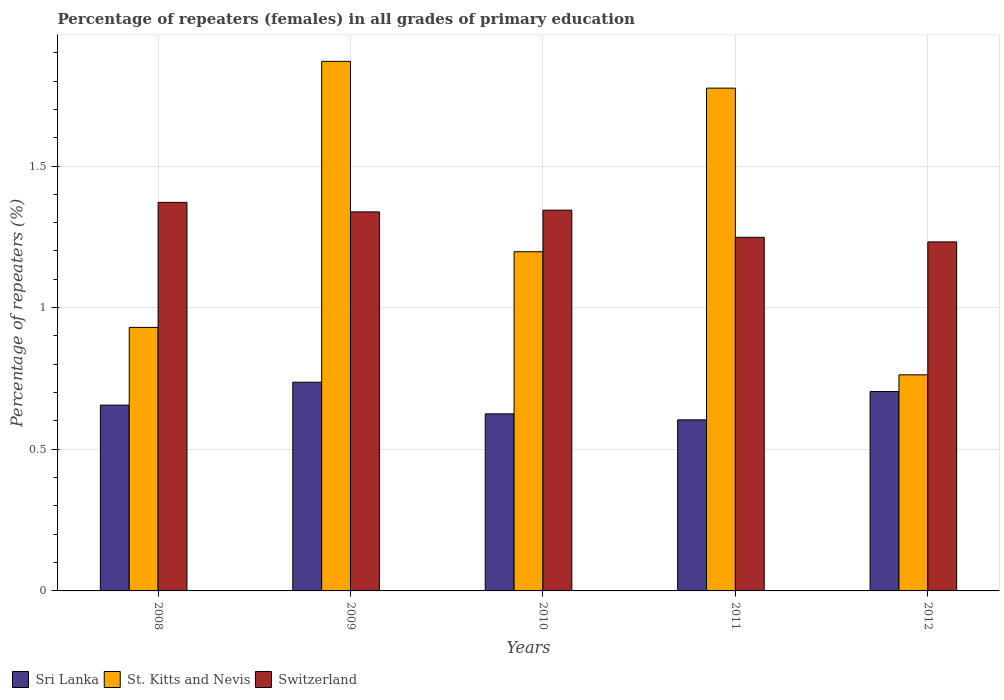How many groups of bars are there?
Your answer should be compact. 5. Are the number of bars per tick equal to the number of legend labels?
Your answer should be compact. Yes. How many bars are there on the 4th tick from the left?
Provide a short and direct response. 3. How many bars are there on the 2nd tick from the right?
Your response must be concise. 3. In how many cases, is the number of bars for a given year not equal to the number of legend labels?
Your response must be concise. 0. What is the percentage of repeaters (females) in St. Kitts and Nevis in 2011?
Provide a succinct answer. 1.77. Across all years, what is the maximum percentage of repeaters (females) in Switzerland?
Provide a short and direct response. 1.37. Across all years, what is the minimum percentage of repeaters (females) in St. Kitts and Nevis?
Provide a short and direct response. 0.76. In which year was the percentage of repeaters (females) in Sri Lanka maximum?
Your answer should be very brief. 2009. In which year was the percentage of repeaters (females) in St. Kitts and Nevis minimum?
Offer a very short reply. 2012. What is the total percentage of repeaters (females) in Switzerland in the graph?
Offer a very short reply. 6.53. What is the difference between the percentage of repeaters (females) in Switzerland in 2011 and that in 2012?
Your answer should be compact. 0.02. What is the difference between the percentage of repeaters (females) in St. Kitts and Nevis in 2009 and the percentage of repeaters (females) in Switzerland in 2012?
Offer a very short reply. 0.64. What is the average percentage of repeaters (females) in Sri Lanka per year?
Keep it short and to the point. 0.67. In the year 2009, what is the difference between the percentage of repeaters (females) in St. Kitts and Nevis and percentage of repeaters (females) in Switzerland?
Offer a very short reply. 0.53. In how many years, is the percentage of repeaters (females) in Switzerland greater than 1.2 %?
Offer a terse response. 5. What is the ratio of the percentage of repeaters (females) in Sri Lanka in 2010 to that in 2011?
Your answer should be very brief. 1.04. Is the difference between the percentage of repeaters (females) in St. Kitts and Nevis in 2009 and 2010 greater than the difference between the percentage of repeaters (females) in Switzerland in 2009 and 2010?
Make the answer very short. Yes. What is the difference between the highest and the second highest percentage of repeaters (females) in Sri Lanka?
Give a very brief answer. 0.03. What is the difference between the highest and the lowest percentage of repeaters (females) in Sri Lanka?
Your answer should be compact. 0.13. What does the 2nd bar from the left in 2010 represents?
Keep it short and to the point. St. Kitts and Nevis. What does the 3rd bar from the right in 2009 represents?
Your answer should be very brief. Sri Lanka. Is it the case that in every year, the sum of the percentage of repeaters (females) in St. Kitts and Nevis and percentage of repeaters (females) in Sri Lanka is greater than the percentage of repeaters (females) in Switzerland?
Keep it short and to the point. Yes. How many bars are there?
Make the answer very short. 15. What is the difference between two consecutive major ticks on the Y-axis?
Your answer should be compact. 0.5. Does the graph contain grids?
Your answer should be very brief. Yes. Where does the legend appear in the graph?
Your answer should be compact. Bottom left. How many legend labels are there?
Your response must be concise. 3. How are the legend labels stacked?
Your answer should be compact. Horizontal. What is the title of the graph?
Your answer should be compact. Percentage of repeaters (females) in all grades of primary education. Does "Papua New Guinea" appear as one of the legend labels in the graph?
Your response must be concise. No. What is the label or title of the Y-axis?
Provide a short and direct response. Percentage of repeaters (%). What is the Percentage of repeaters (%) of Sri Lanka in 2008?
Ensure brevity in your answer.  0.66. What is the Percentage of repeaters (%) in St. Kitts and Nevis in 2008?
Offer a terse response. 0.93. What is the Percentage of repeaters (%) in Switzerland in 2008?
Make the answer very short. 1.37. What is the Percentage of repeaters (%) in Sri Lanka in 2009?
Give a very brief answer. 0.74. What is the Percentage of repeaters (%) of St. Kitts and Nevis in 2009?
Make the answer very short. 1.87. What is the Percentage of repeaters (%) in Switzerland in 2009?
Give a very brief answer. 1.34. What is the Percentage of repeaters (%) in Sri Lanka in 2010?
Give a very brief answer. 0.63. What is the Percentage of repeaters (%) of St. Kitts and Nevis in 2010?
Provide a succinct answer. 1.2. What is the Percentage of repeaters (%) in Switzerland in 2010?
Your answer should be very brief. 1.34. What is the Percentage of repeaters (%) in Sri Lanka in 2011?
Keep it short and to the point. 0.6. What is the Percentage of repeaters (%) of St. Kitts and Nevis in 2011?
Provide a succinct answer. 1.77. What is the Percentage of repeaters (%) in Switzerland in 2011?
Provide a succinct answer. 1.25. What is the Percentage of repeaters (%) of Sri Lanka in 2012?
Give a very brief answer. 0.7. What is the Percentage of repeaters (%) of St. Kitts and Nevis in 2012?
Provide a succinct answer. 0.76. What is the Percentage of repeaters (%) of Switzerland in 2012?
Provide a succinct answer. 1.23. Across all years, what is the maximum Percentage of repeaters (%) in Sri Lanka?
Provide a succinct answer. 0.74. Across all years, what is the maximum Percentage of repeaters (%) of St. Kitts and Nevis?
Make the answer very short. 1.87. Across all years, what is the maximum Percentage of repeaters (%) in Switzerland?
Your response must be concise. 1.37. Across all years, what is the minimum Percentage of repeaters (%) in Sri Lanka?
Your answer should be compact. 0.6. Across all years, what is the minimum Percentage of repeaters (%) of St. Kitts and Nevis?
Provide a short and direct response. 0.76. Across all years, what is the minimum Percentage of repeaters (%) of Switzerland?
Provide a succinct answer. 1.23. What is the total Percentage of repeaters (%) of Sri Lanka in the graph?
Provide a short and direct response. 3.33. What is the total Percentage of repeaters (%) of St. Kitts and Nevis in the graph?
Offer a terse response. 6.53. What is the total Percentage of repeaters (%) in Switzerland in the graph?
Your response must be concise. 6.53. What is the difference between the Percentage of repeaters (%) in Sri Lanka in 2008 and that in 2009?
Your answer should be very brief. -0.08. What is the difference between the Percentage of repeaters (%) in St. Kitts and Nevis in 2008 and that in 2009?
Offer a terse response. -0.94. What is the difference between the Percentage of repeaters (%) in Switzerland in 2008 and that in 2009?
Your response must be concise. 0.03. What is the difference between the Percentage of repeaters (%) of Sri Lanka in 2008 and that in 2010?
Your answer should be compact. 0.03. What is the difference between the Percentage of repeaters (%) of St. Kitts and Nevis in 2008 and that in 2010?
Provide a succinct answer. -0.27. What is the difference between the Percentage of repeaters (%) of Switzerland in 2008 and that in 2010?
Make the answer very short. 0.03. What is the difference between the Percentage of repeaters (%) of Sri Lanka in 2008 and that in 2011?
Your answer should be compact. 0.05. What is the difference between the Percentage of repeaters (%) of St. Kitts and Nevis in 2008 and that in 2011?
Your answer should be compact. -0.84. What is the difference between the Percentage of repeaters (%) of Switzerland in 2008 and that in 2011?
Provide a succinct answer. 0.12. What is the difference between the Percentage of repeaters (%) of Sri Lanka in 2008 and that in 2012?
Give a very brief answer. -0.05. What is the difference between the Percentage of repeaters (%) of St. Kitts and Nevis in 2008 and that in 2012?
Your answer should be compact. 0.17. What is the difference between the Percentage of repeaters (%) of Switzerland in 2008 and that in 2012?
Your answer should be compact. 0.14. What is the difference between the Percentage of repeaters (%) in Sri Lanka in 2009 and that in 2010?
Ensure brevity in your answer.  0.11. What is the difference between the Percentage of repeaters (%) in St. Kitts and Nevis in 2009 and that in 2010?
Make the answer very short. 0.67. What is the difference between the Percentage of repeaters (%) of Switzerland in 2009 and that in 2010?
Your answer should be very brief. -0.01. What is the difference between the Percentage of repeaters (%) in Sri Lanka in 2009 and that in 2011?
Provide a succinct answer. 0.13. What is the difference between the Percentage of repeaters (%) of St. Kitts and Nevis in 2009 and that in 2011?
Your answer should be compact. 0.09. What is the difference between the Percentage of repeaters (%) in Switzerland in 2009 and that in 2011?
Offer a very short reply. 0.09. What is the difference between the Percentage of repeaters (%) in Sri Lanka in 2009 and that in 2012?
Your response must be concise. 0.03. What is the difference between the Percentage of repeaters (%) in St. Kitts and Nevis in 2009 and that in 2012?
Your answer should be compact. 1.11. What is the difference between the Percentage of repeaters (%) in Switzerland in 2009 and that in 2012?
Keep it short and to the point. 0.11. What is the difference between the Percentage of repeaters (%) in Sri Lanka in 2010 and that in 2011?
Your response must be concise. 0.02. What is the difference between the Percentage of repeaters (%) of St. Kitts and Nevis in 2010 and that in 2011?
Provide a succinct answer. -0.58. What is the difference between the Percentage of repeaters (%) in Switzerland in 2010 and that in 2011?
Offer a terse response. 0.1. What is the difference between the Percentage of repeaters (%) of Sri Lanka in 2010 and that in 2012?
Give a very brief answer. -0.08. What is the difference between the Percentage of repeaters (%) of St. Kitts and Nevis in 2010 and that in 2012?
Offer a terse response. 0.43. What is the difference between the Percentage of repeaters (%) in Switzerland in 2010 and that in 2012?
Provide a short and direct response. 0.11. What is the difference between the Percentage of repeaters (%) in Sri Lanka in 2011 and that in 2012?
Your response must be concise. -0.1. What is the difference between the Percentage of repeaters (%) in St. Kitts and Nevis in 2011 and that in 2012?
Your answer should be very brief. 1.01. What is the difference between the Percentage of repeaters (%) in Switzerland in 2011 and that in 2012?
Your answer should be compact. 0.02. What is the difference between the Percentage of repeaters (%) in Sri Lanka in 2008 and the Percentage of repeaters (%) in St. Kitts and Nevis in 2009?
Your response must be concise. -1.21. What is the difference between the Percentage of repeaters (%) of Sri Lanka in 2008 and the Percentage of repeaters (%) of Switzerland in 2009?
Make the answer very short. -0.68. What is the difference between the Percentage of repeaters (%) in St. Kitts and Nevis in 2008 and the Percentage of repeaters (%) in Switzerland in 2009?
Your answer should be very brief. -0.41. What is the difference between the Percentage of repeaters (%) in Sri Lanka in 2008 and the Percentage of repeaters (%) in St. Kitts and Nevis in 2010?
Offer a very short reply. -0.54. What is the difference between the Percentage of repeaters (%) in Sri Lanka in 2008 and the Percentage of repeaters (%) in Switzerland in 2010?
Keep it short and to the point. -0.69. What is the difference between the Percentage of repeaters (%) of St. Kitts and Nevis in 2008 and the Percentage of repeaters (%) of Switzerland in 2010?
Keep it short and to the point. -0.41. What is the difference between the Percentage of repeaters (%) of Sri Lanka in 2008 and the Percentage of repeaters (%) of St. Kitts and Nevis in 2011?
Keep it short and to the point. -1.12. What is the difference between the Percentage of repeaters (%) of Sri Lanka in 2008 and the Percentage of repeaters (%) of Switzerland in 2011?
Offer a very short reply. -0.59. What is the difference between the Percentage of repeaters (%) in St. Kitts and Nevis in 2008 and the Percentage of repeaters (%) in Switzerland in 2011?
Offer a terse response. -0.32. What is the difference between the Percentage of repeaters (%) in Sri Lanka in 2008 and the Percentage of repeaters (%) in St. Kitts and Nevis in 2012?
Offer a very short reply. -0.11. What is the difference between the Percentage of repeaters (%) in Sri Lanka in 2008 and the Percentage of repeaters (%) in Switzerland in 2012?
Make the answer very short. -0.58. What is the difference between the Percentage of repeaters (%) of St. Kitts and Nevis in 2008 and the Percentage of repeaters (%) of Switzerland in 2012?
Provide a short and direct response. -0.3. What is the difference between the Percentage of repeaters (%) of Sri Lanka in 2009 and the Percentage of repeaters (%) of St. Kitts and Nevis in 2010?
Your answer should be compact. -0.46. What is the difference between the Percentage of repeaters (%) in Sri Lanka in 2009 and the Percentage of repeaters (%) in Switzerland in 2010?
Offer a terse response. -0.61. What is the difference between the Percentage of repeaters (%) in St. Kitts and Nevis in 2009 and the Percentage of repeaters (%) in Switzerland in 2010?
Ensure brevity in your answer.  0.53. What is the difference between the Percentage of repeaters (%) in Sri Lanka in 2009 and the Percentage of repeaters (%) in St. Kitts and Nevis in 2011?
Offer a terse response. -1.04. What is the difference between the Percentage of repeaters (%) of Sri Lanka in 2009 and the Percentage of repeaters (%) of Switzerland in 2011?
Make the answer very short. -0.51. What is the difference between the Percentage of repeaters (%) in St. Kitts and Nevis in 2009 and the Percentage of repeaters (%) in Switzerland in 2011?
Keep it short and to the point. 0.62. What is the difference between the Percentage of repeaters (%) in Sri Lanka in 2009 and the Percentage of repeaters (%) in St. Kitts and Nevis in 2012?
Offer a terse response. -0.03. What is the difference between the Percentage of repeaters (%) in Sri Lanka in 2009 and the Percentage of repeaters (%) in Switzerland in 2012?
Your answer should be compact. -0.5. What is the difference between the Percentage of repeaters (%) of St. Kitts and Nevis in 2009 and the Percentage of repeaters (%) of Switzerland in 2012?
Provide a succinct answer. 0.64. What is the difference between the Percentage of repeaters (%) of Sri Lanka in 2010 and the Percentage of repeaters (%) of St. Kitts and Nevis in 2011?
Provide a short and direct response. -1.15. What is the difference between the Percentage of repeaters (%) in Sri Lanka in 2010 and the Percentage of repeaters (%) in Switzerland in 2011?
Make the answer very short. -0.62. What is the difference between the Percentage of repeaters (%) of St. Kitts and Nevis in 2010 and the Percentage of repeaters (%) of Switzerland in 2011?
Your answer should be compact. -0.05. What is the difference between the Percentage of repeaters (%) in Sri Lanka in 2010 and the Percentage of repeaters (%) in St. Kitts and Nevis in 2012?
Your answer should be very brief. -0.14. What is the difference between the Percentage of repeaters (%) of Sri Lanka in 2010 and the Percentage of repeaters (%) of Switzerland in 2012?
Ensure brevity in your answer.  -0.61. What is the difference between the Percentage of repeaters (%) of St. Kitts and Nevis in 2010 and the Percentage of repeaters (%) of Switzerland in 2012?
Keep it short and to the point. -0.03. What is the difference between the Percentage of repeaters (%) in Sri Lanka in 2011 and the Percentage of repeaters (%) in St. Kitts and Nevis in 2012?
Offer a very short reply. -0.16. What is the difference between the Percentage of repeaters (%) of Sri Lanka in 2011 and the Percentage of repeaters (%) of Switzerland in 2012?
Make the answer very short. -0.63. What is the difference between the Percentage of repeaters (%) of St. Kitts and Nevis in 2011 and the Percentage of repeaters (%) of Switzerland in 2012?
Offer a very short reply. 0.54. What is the average Percentage of repeaters (%) of Sri Lanka per year?
Provide a short and direct response. 0.67. What is the average Percentage of repeaters (%) in St. Kitts and Nevis per year?
Your response must be concise. 1.31. What is the average Percentage of repeaters (%) of Switzerland per year?
Make the answer very short. 1.31. In the year 2008, what is the difference between the Percentage of repeaters (%) of Sri Lanka and Percentage of repeaters (%) of St. Kitts and Nevis?
Provide a succinct answer. -0.27. In the year 2008, what is the difference between the Percentage of repeaters (%) in Sri Lanka and Percentage of repeaters (%) in Switzerland?
Your answer should be very brief. -0.72. In the year 2008, what is the difference between the Percentage of repeaters (%) in St. Kitts and Nevis and Percentage of repeaters (%) in Switzerland?
Your response must be concise. -0.44. In the year 2009, what is the difference between the Percentage of repeaters (%) of Sri Lanka and Percentage of repeaters (%) of St. Kitts and Nevis?
Provide a short and direct response. -1.13. In the year 2009, what is the difference between the Percentage of repeaters (%) in Sri Lanka and Percentage of repeaters (%) in Switzerland?
Your response must be concise. -0.6. In the year 2009, what is the difference between the Percentage of repeaters (%) of St. Kitts and Nevis and Percentage of repeaters (%) of Switzerland?
Ensure brevity in your answer.  0.53. In the year 2010, what is the difference between the Percentage of repeaters (%) of Sri Lanka and Percentage of repeaters (%) of St. Kitts and Nevis?
Keep it short and to the point. -0.57. In the year 2010, what is the difference between the Percentage of repeaters (%) of Sri Lanka and Percentage of repeaters (%) of Switzerland?
Keep it short and to the point. -0.72. In the year 2010, what is the difference between the Percentage of repeaters (%) of St. Kitts and Nevis and Percentage of repeaters (%) of Switzerland?
Ensure brevity in your answer.  -0.15. In the year 2011, what is the difference between the Percentage of repeaters (%) in Sri Lanka and Percentage of repeaters (%) in St. Kitts and Nevis?
Keep it short and to the point. -1.17. In the year 2011, what is the difference between the Percentage of repeaters (%) in Sri Lanka and Percentage of repeaters (%) in Switzerland?
Ensure brevity in your answer.  -0.64. In the year 2011, what is the difference between the Percentage of repeaters (%) of St. Kitts and Nevis and Percentage of repeaters (%) of Switzerland?
Keep it short and to the point. 0.53. In the year 2012, what is the difference between the Percentage of repeaters (%) in Sri Lanka and Percentage of repeaters (%) in St. Kitts and Nevis?
Make the answer very short. -0.06. In the year 2012, what is the difference between the Percentage of repeaters (%) of Sri Lanka and Percentage of repeaters (%) of Switzerland?
Ensure brevity in your answer.  -0.53. In the year 2012, what is the difference between the Percentage of repeaters (%) of St. Kitts and Nevis and Percentage of repeaters (%) of Switzerland?
Your response must be concise. -0.47. What is the ratio of the Percentage of repeaters (%) of Sri Lanka in 2008 to that in 2009?
Keep it short and to the point. 0.89. What is the ratio of the Percentage of repeaters (%) in St. Kitts and Nevis in 2008 to that in 2009?
Keep it short and to the point. 0.5. What is the ratio of the Percentage of repeaters (%) in Switzerland in 2008 to that in 2009?
Offer a terse response. 1.03. What is the ratio of the Percentage of repeaters (%) in Sri Lanka in 2008 to that in 2010?
Keep it short and to the point. 1.05. What is the ratio of the Percentage of repeaters (%) of St. Kitts and Nevis in 2008 to that in 2010?
Provide a succinct answer. 0.78. What is the ratio of the Percentage of repeaters (%) of Switzerland in 2008 to that in 2010?
Keep it short and to the point. 1.02. What is the ratio of the Percentage of repeaters (%) of Sri Lanka in 2008 to that in 2011?
Make the answer very short. 1.09. What is the ratio of the Percentage of repeaters (%) in St. Kitts and Nevis in 2008 to that in 2011?
Give a very brief answer. 0.52. What is the ratio of the Percentage of repeaters (%) of Switzerland in 2008 to that in 2011?
Offer a very short reply. 1.1. What is the ratio of the Percentage of repeaters (%) of Sri Lanka in 2008 to that in 2012?
Offer a terse response. 0.93. What is the ratio of the Percentage of repeaters (%) of St. Kitts and Nevis in 2008 to that in 2012?
Your answer should be compact. 1.22. What is the ratio of the Percentage of repeaters (%) of Switzerland in 2008 to that in 2012?
Give a very brief answer. 1.11. What is the ratio of the Percentage of repeaters (%) of Sri Lanka in 2009 to that in 2010?
Offer a terse response. 1.18. What is the ratio of the Percentage of repeaters (%) of St. Kitts and Nevis in 2009 to that in 2010?
Provide a succinct answer. 1.56. What is the ratio of the Percentage of repeaters (%) of Switzerland in 2009 to that in 2010?
Offer a very short reply. 1. What is the ratio of the Percentage of repeaters (%) in Sri Lanka in 2009 to that in 2011?
Offer a very short reply. 1.22. What is the ratio of the Percentage of repeaters (%) in St. Kitts and Nevis in 2009 to that in 2011?
Your answer should be very brief. 1.05. What is the ratio of the Percentage of repeaters (%) in Switzerland in 2009 to that in 2011?
Offer a terse response. 1.07. What is the ratio of the Percentage of repeaters (%) of Sri Lanka in 2009 to that in 2012?
Your answer should be very brief. 1.05. What is the ratio of the Percentage of repeaters (%) in St. Kitts and Nevis in 2009 to that in 2012?
Keep it short and to the point. 2.45. What is the ratio of the Percentage of repeaters (%) of Switzerland in 2009 to that in 2012?
Your response must be concise. 1.09. What is the ratio of the Percentage of repeaters (%) of Sri Lanka in 2010 to that in 2011?
Your answer should be very brief. 1.03. What is the ratio of the Percentage of repeaters (%) in St. Kitts and Nevis in 2010 to that in 2011?
Offer a very short reply. 0.67. What is the ratio of the Percentage of repeaters (%) in Switzerland in 2010 to that in 2011?
Provide a short and direct response. 1.08. What is the ratio of the Percentage of repeaters (%) of Sri Lanka in 2010 to that in 2012?
Provide a succinct answer. 0.89. What is the ratio of the Percentage of repeaters (%) in St. Kitts and Nevis in 2010 to that in 2012?
Offer a very short reply. 1.57. What is the ratio of the Percentage of repeaters (%) of Sri Lanka in 2011 to that in 2012?
Your response must be concise. 0.86. What is the ratio of the Percentage of repeaters (%) of St. Kitts and Nevis in 2011 to that in 2012?
Your response must be concise. 2.33. What is the ratio of the Percentage of repeaters (%) of Switzerland in 2011 to that in 2012?
Your answer should be compact. 1.01. What is the difference between the highest and the second highest Percentage of repeaters (%) of Sri Lanka?
Give a very brief answer. 0.03. What is the difference between the highest and the second highest Percentage of repeaters (%) of St. Kitts and Nevis?
Give a very brief answer. 0.09. What is the difference between the highest and the second highest Percentage of repeaters (%) in Switzerland?
Make the answer very short. 0.03. What is the difference between the highest and the lowest Percentage of repeaters (%) of Sri Lanka?
Give a very brief answer. 0.13. What is the difference between the highest and the lowest Percentage of repeaters (%) in St. Kitts and Nevis?
Provide a succinct answer. 1.11. What is the difference between the highest and the lowest Percentage of repeaters (%) of Switzerland?
Provide a short and direct response. 0.14. 